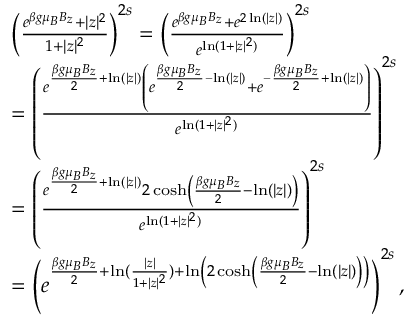Convert formula to latex. <formula><loc_0><loc_0><loc_500><loc_500>\begin{array} { r l } & { \left ( \frac { e ^ { \beta g \mu _ { B } B _ { z } } + | z | ^ { 2 } } { 1 + | z | ^ { 2 } } \right ) ^ { 2 s } = \left ( \frac { e ^ { \beta g \mu _ { B } B _ { z } } + e ^ { 2 \ln ( | z | ) } } { e ^ { \ln ( 1 + | z | ^ { 2 } ) } } \right ) ^ { 2 s } } \\ & { = \left ( \frac { e ^ { \frac { \beta g \mu _ { B } B _ { z } } { 2 } + \ln ( | z | ) } \left ( e ^ { \frac { \beta g \mu _ { B } B _ { z } } { 2 } - \ln ( | z | ) } + e ^ { - \frac { \beta g \mu _ { B } B _ { z } } { 2 } + \ln ( | z | ) } \right ) } { e ^ { \ln ( 1 + | z | ^ { 2 } ) } } \right ) ^ { 2 s } } \\ & { = \left ( \frac { e ^ { \frac { \beta g \mu _ { B } B _ { z } } { 2 } + \ln ( | z | ) } 2 \cosh \left ( \frac { \beta g \mu _ { B } B _ { z } } { 2 } - \ln ( | z | ) \right ) } { e ^ { \ln ( 1 + | z | ^ { 2 } ) } } \right ) ^ { 2 s } } \\ & { = \left ( e ^ { \frac { \beta g \mu _ { B } B _ { z } } { 2 } + \ln ( \frac { | z | } { 1 + | z | ^ { 2 } } ) + \ln \left ( 2 \cosh \left ( \frac { \beta g \mu _ { B } B _ { z } } { 2 } - \ln ( | z | ) \right ) \right ) } \right ) ^ { 2 s } , } \end{array}</formula> 